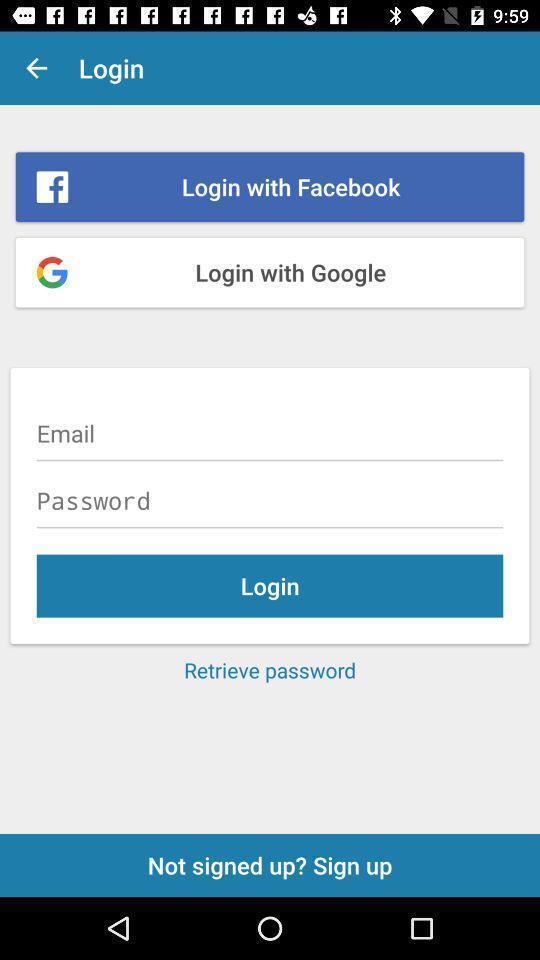Tell me what you see in this picture. Screen displaying multiple login options. 